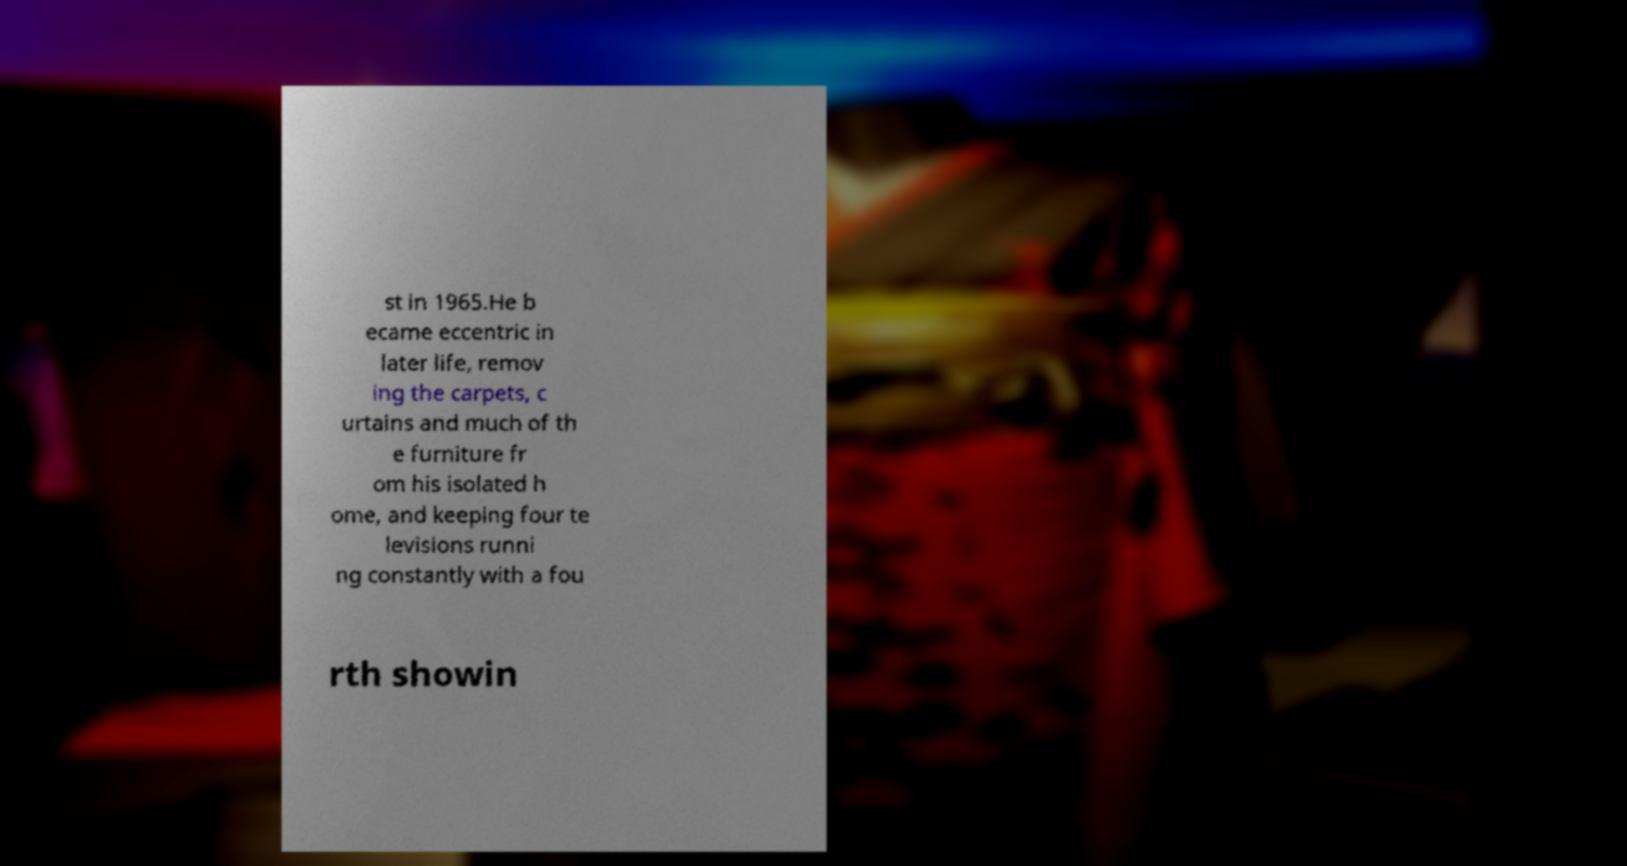Could you extract and type out the text from this image? st in 1965.He b ecame eccentric in later life, remov ing the carpets, c urtains and much of th e furniture fr om his isolated h ome, and keeping four te levisions runni ng constantly with a fou rth showin 